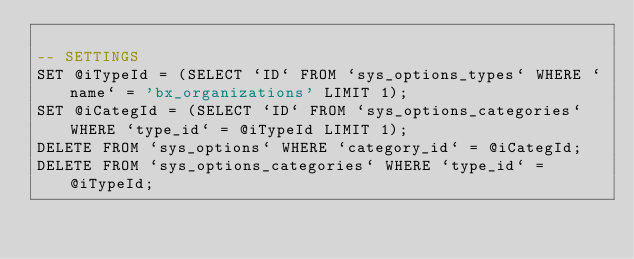<code> <loc_0><loc_0><loc_500><loc_500><_SQL_>
-- SETTINGS
SET @iTypeId = (SELECT `ID` FROM `sys_options_types` WHERE `name` = 'bx_organizations' LIMIT 1);
SET @iCategId = (SELECT `ID` FROM `sys_options_categories` WHERE `type_id` = @iTypeId LIMIT 1);
DELETE FROM `sys_options` WHERE `category_id` = @iCategId;
DELETE FROM `sys_options_categories` WHERE `type_id` = @iTypeId;</code> 